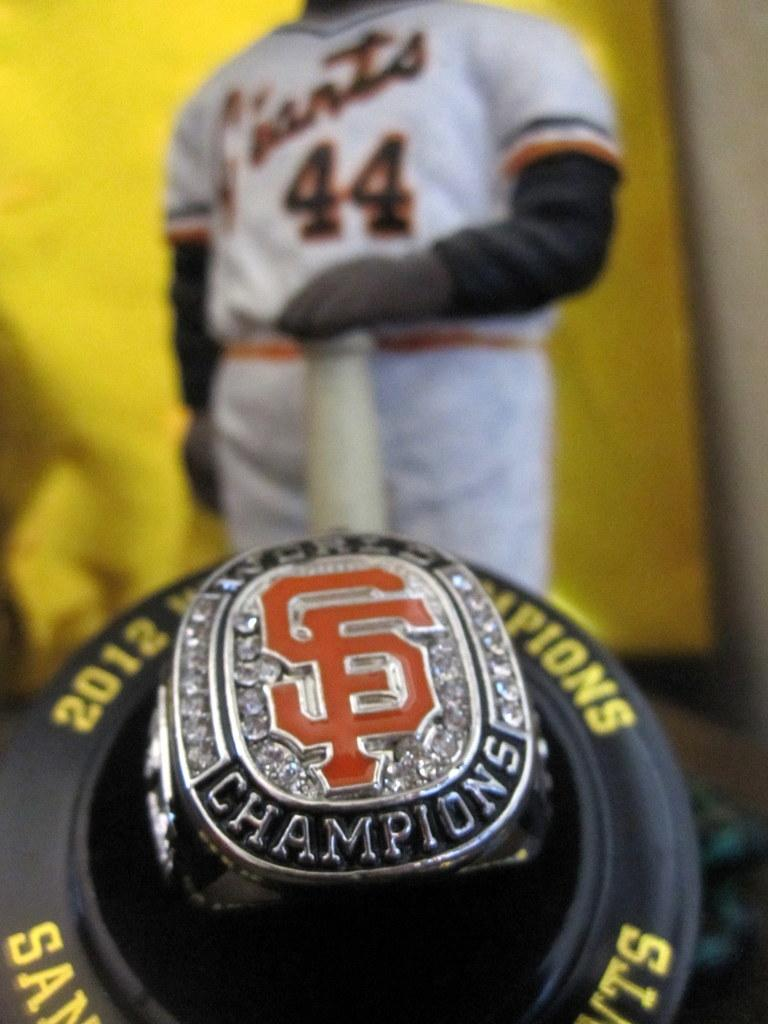Provide a one-sentence caption for the provided image. San Francisco Giants player #44 is standing behind a 2012 Championship ring. 